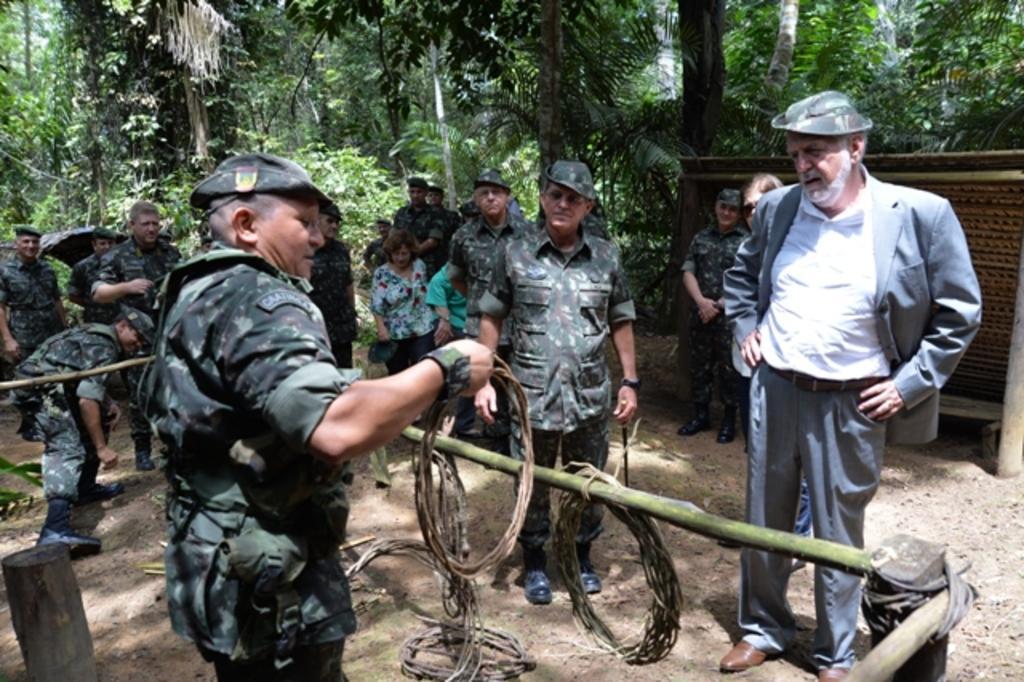Describe this image in one or two sentences. In this image I see number of people in which most of them are wearing army uniform and I see the bamboo sticks over here and I see that this man is holding a brown color thing in his hand and I see the ground and I see 3 more brown color things over here. In the background I see the wall and I see the trees. 